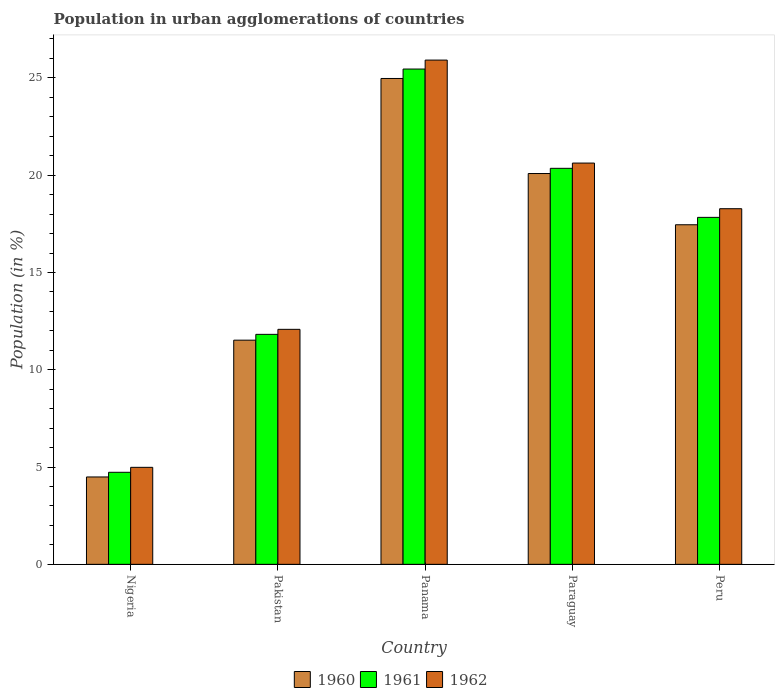How many groups of bars are there?
Offer a terse response. 5. How many bars are there on the 3rd tick from the left?
Your answer should be very brief. 3. What is the label of the 5th group of bars from the left?
Provide a succinct answer. Peru. In how many cases, is the number of bars for a given country not equal to the number of legend labels?
Give a very brief answer. 0. What is the percentage of population in urban agglomerations in 1961 in Peru?
Your response must be concise. 17.83. Across all countries, what is the maximum percentage of population in urban agglomerations in 1960?
Give a very brief answer. 24.97. Across all countries, what is the minimum percentage of population in urban agglomerations in 1962?
Ensure brevity in your answer.  4.99. In which country was the percentage of population in urban agglomerations in 1962 maximum?
Offer a very short reply. Panama. In which country was the percentage of population in urban agglomerations in 1961 minimum?
Ensure brevity in your answer.  Nigeria. What is the total percentage of population in urban agglomerations in 1961 in the graph?
Provide a succinct answer. 80.19. What is the difference between the percentage of population in urban agglomerations in 1960 in Pakistan and that in Peru?
Provide a short and direct response. -5.93. What is the difference between the percentage of population in urban agglomerations in 1960 in Panama and the percentage of population in urban agglomerations in 1962 in Pakistan?
Make the answer very short. 12.89. What is the average percentage of population in urban agglomerations in 1960 per country?
Provide a succinct answer. 15.7. What is the difference between the percentage of population in urban agglomerations of/in 1961 and percentage of population in urban agglomerations of/in 1962 in Nigeria?
Ensure brevity in your answer.  -0.26. What is the ratio of the percentage of population in urban agglomerations in 1960 in Nigeria to that in Paraguay?
Provide a succinct answer. 0.22. Is the percentage of population in urban agglomerations in 1962 in Nigeria less than that in Paraguay?
Your response must be concise. Yes. What is the difference between the highest and the second highest percentage of population in urban agglomerations in 1961?
Provide a succinct answer. 5.1. What is the difference between the highest and the lowest percentage of population in urban agglomerations in 1960?
Give a very brief answer. 20.48. What does the 2nd bar from the left in Peru represents?
Offer a terse response. 1961. How many bars are there?
Your answer should be very brief. 15. What is the difference between two consecutive major ticks on the Y-axis?
Offer a terse response. 5. Does the graph contain grids?
Provide a succinct answer. No. How many legend labels are there?
Give a very brief answer. 3. What is the title of the graph?
Make the answer very short. Population in urban agglomerations of countries. Does "2008" appear as one of the legend labels in the graph?
Your answer should be compact. No. What is the Population (in %) of 1960 in Nigeria?
Make the answer very short. 4.49. What is the Population (in %) of 1961 in Nigeria?
Ensure brevity in your answer.  4.73. What is the Population (in %) of 1962 in Nigeria?
Keep it short and to the point. 4.99. What is the Population (in %) of 1960 in Pakistan?
Make the answer very short. 11.52. What is the Population (in %) in 1961 in Pakistan?
Provide a short and direct response. 11.82. What is the Population (in %) in 1962 in Pakistan?
Give a very brief answer. 12.08. What is the Population (in %) of 1960 in Panama?
Your answer should be very brief. 24.97. What is the Population (in %) in 1961 in Panama?
Ensure brevity in your answer.  25.46. What is the Population (in %) of 1962 in Panama?
Ensure brevity in your answer.  25.92. What is the Population (in %) of 1960 in Paraguay?
Give a very brief answer. 20.08. What is the Population (in %) in 1961 in Paraguay?
Provide a succinct answer. 20.35. What is the Population (in %) of 1962 in Paraguay?
Provide a succinct answer. 20.62. What is the Population (in %) in 1960 in Peru?
Your answer should be very brief. 17.45. What is the Population (in %) in 1961 in Peru?
Make the answer very short. 17.83. What is the Population (in %) of 1962 in Peru?
Provide a succinct answer. 18.28. Across all countries, what is the maximum Population (in %) in 1960?
Your response must be concise. 24.97. Across all countries, what is the maximum Population (in %) in 1961?
Offer a very short reply. 25.46. Across all countries, what is the maximum Population (in %) in 1962?
Your response must be concise. 25.92. Across all countries, what is the minimum Population (in %) of 1960?
Give a very brief answer. 4.49. Across all countries, what is the minimum Population (in %) of 1961?
Your answer should be compact. 4.73. Across all countries, what is the minimum Population (in %) in 1962?
Provide a short and direct response. 4.99. What is the total Population (in %) in 1960 in the graph?
Your response must be concise. 78.52. What is the total Population (in %) of 1961 in the graph?
Provide a succinct answer. 80.19. What is the total Population (in %) of 1962 in the graph?
Give a very brief answer. 81.88. What is the difference between the Population (in %) in 1960 in Nigeria and that in Pakistan?
Your response must be concise. -7.03. What is the difference between the Population (in %) of 1961 in Nigeria and that in Pakistan?
Your response must be concise. -7.09. What is the difference between the Population (in %) in 1962 in Nigeria and that in Pakistan?
Offer a terse response. -7.09. What is the difference between the Population (in %) of 1960 in Nigeria and that in Panama?
Provide a short and direct response. -20.48. What is the difference between the Population (in %) in 1961 in Nigeria and that in Panama?
Ensure brevity in your answer.  -20.72. What is the difference between the Population (in %) in 1962 in Nigeria and that in Panama?
Make the answer very short. -20.93. What is the difference between the Population (in %) in 1960 in Nigeria and that in Paraguay?
Keep it short and to the point. -15.59. What is the difference between the Population (in %) of 1961 in Nigeria and that in Paraguay?
Keep it short and to the point. -15.62. What is the difference between the Population (in %) of 1962 in Nigeria and that in Paraguay?
Provide a succinct answer. -15.64. What is the difference between the Population (in %) in 1960 in Nigeria and that in Peru?
Give a very brief answer. -12.96. What is the difference between the Population (in %) in 1961 in Nigeria and that in Peru?
Your answer should be compact. -13.1. What is the difference between the Population (in %) of 1962 in Nigeria and that in Peru?
Your answer should be very brief. -13.29. What is the difference between the Population (in %) of 1960 in Pakistan and that in Panama?
Keep it short and to the point. -13.45. What is the difference between the Population (in %) of 1961 in Pakistan and that in Panama?
Your response must be concise. -13.64. What is the difference between the Population (in %) in 1962 in Pakistan and that in Panama?
Offer a very short reply. -13.84. What is the difference between the Population (in %) in 1960 in Pakistan and that in Paraguay?
Your answer should be very brief. -8.56. What is the difference between the Population (in %) of 1961 in Pakistan and that in Paraguay?
Your answer should be compact. -8.53. What is the difference between the Population (in %) of 1962 in Pakistan and that in Paraguay?
Offer a terse response. -8.55. What is the difference between the Population (in %) of 1960 in Pakistan and that in Peru?
Offer a very short reply. -5.93. What is the difference between the Population (in %) of 1961 in Pakistan and that in Peru?
Offer a very short reply. -6.01. What is the difference between the Population (in %) of 1962 in Pakistan and that in Peru?
Your answer should be compact. -6.2. What is the difference between the Population (in %) in 1960 in Panama and that in Paraguay?
Ensure brevity in your answer.  4.89. What is the difference between the Population (in %) in 1961 in Panama and that in Paraguay?
Offer a very short reply. 5.1. What is the difference between the Population (in %) of 1962 in Panama and that in Paraguay?
Your response must be concise. 5.29. What is the difference between the Population (in %) of 1960 in Panama and that in Peru?
Offer a terse response. 7.52. What is the difference between the Population (in %) of 1961 in Panama and that in Peru?
Make the answer very short. 7.62. What is the difference between the Population (in %) of 1962 in Panama and that in Peru?
Provide a short and direct response. 7.64. What is the difference between the Population (in %) of 1960 in Paraguay and that in Peru?
Give a very brief answer. 2.63. What is the difference between the Population (in %) of 1961 in Paraguay and that in Peru?
Your answer should be compact. 2.52. What is the difference between the Population (in %) in 1962 in Paraguay and that in Peru?
Provide a short and direct response. 2.35. What is the difference between the Population (in %) of 1960 in Nigeria and the Population (in %) of 1961 in Pakistan?
Make the answer very short. -7.33. What is the difference between the Population (in %) of 1960 in Nigeria and the Population (in %) of 1962 in Pakistan?
Keep it short and to the point. -7.59. What is the difference between the Population (in %) of 1961 in Nigeria and the Population (in %) of 1962 in Pakistan?
Provide a succinct answer. -7.35. What is the difference between the Population (in %) in 1960 in Nigeria and the Population (in %) in 1961 in Panama?
Your answer should be very brief. -20.96. What is the difference between the Population (in %) of 1960 in Nigeria and the Population (in %) of 1962 in Panama?
Keep it short and to the point. -21.42. What is the difference between the Population (in %) in 1961 in Nigeria and the Population (in %) in 1962 in Panama?
Provide a succinct answer. -21.18. What is the difference between the Population (in %) of 1960 in Nigeria and the Population (in %) of 1961 in Paraguay?
Your answer should be very brief. -15.86. What is the difference between the Population (in %) of 1960 in Nigeria and the Population (in %) of 1962 in Paraguay?
Offer a terse response. -16.13. What is the difference between the Population (in %) of 1961 in Nigeria and the Population (in %) of 1962 in Paraguay?
Make the answer very short. -15.89. What is the difference between the Population (in %) in 1960 in Nigeria and the Population (in %) in 1961 in Peru?
Offer a terse response. -13.34. What is the difference between the Population (in %) in 1960 in Nigeria and the Population (in %) in 1962 in Peru?
Keep it short and to the point. -13.79. What is the difference between the Population (in %) of 1961 in Nigeria and the Population (in %) of 1962 in Peru?
Ensure brevity in your answer.  -13.55. What is the difference between the Population (in %) of 1960 in Pakistan and the Population (in %) of 1961 in Panama?
Offer a terse response. -13.93. What is the difference between the Population (in %) of 1960 in Pakistan and the Population (in %) of 1962 in Panama?
Your answer should be very brief. -14.39. What is the difference between the Population (in %) in 1961 in Pakistan and the Population (in %) in 1962 in Panama?
Your response must be concise. -14.1. What is the difference between the Population (in %) of 1960 in Pakistan and the Population (in %) of 1961 in Paraguay?
Provide a short and direct response. -8.83. What is the difference between the Population (in %) of 1960 in Pakistan and the Population (in %) of 1962 in Paraguay?
Make the answer very short. -9.1. What is the difference between the Population (in %) of 1961 in Pakistan and the Population (in %) of 1962 in Paraguay?
Provide a short and direct response. -8.8. What is the difference between the Population (in %) of 1960 in Pakistan and the Population (in %) of 1961 in Peru?
Your answer should be compact. -6.31. What is the difference between the Population (in %) in 1960 in Pakistan and the Population (in %) in 1962 in Peru?
Provide a succinct answer. -6.76. What is the difference between the Population (in %) of 1961 in Pakistan and the Population (in %) of 1962 in Peru?
Offer a terse response. -6.46. What is the difference between the Population (in %) of 1960 in Panama and the Population (in %) of 1961 in Paraguay?
Make the answer very short. 4.62. What is the difference between the Population (in %) in 1960 in Panama and the Population (in %) in 1962 in Paraguay?
Your response must be concise. 4.35. What is the difference between the Population (in %) of 1961 in Panama and the Population (in %) of 1962 in Paraguay?
Your answer should be very brief. 4.83. What is the difference between the Population (in %) of 1960 in Panama and the Population (in %) of 1961 in Peru?
Ensure brevity in your answer.  7.14. What is the difference between the Population (in %) in 1960 in Panama and the Population (in %) in 1962 in Peru?
Give a very brief answer. 6.69. What is the difference between the Population (in %) in 1961 in Panama and the Population (in %) in 1962 in Peru?
Keep it short and to the point. 7.18. What is the difference between the Population (in %) in 1960 in Paraguay and the Population (in %) in 1961 in Peru?
Ensure brevity in your answer.  2.25. What is the difference between the Population (in %) of 1960 in Paraguay and the Population (in %) of 1962 in Peru?
Your response must be concise. 1.81. What is the difference between the Population (in %) of 1961 in Paraguay and the Population (in %) of 1962 in Peru?
Keep it short and to the point. 2.08. What is the average Population (in %) in 1960 per country?
Your answer should be very brief. 15.7. What is the average Population (in %) of 1961 per country?
Provide a succinct answer. 16.04. What is the average Population (in %) in 1962 per country?
Ensure brevity in your answer.  16.38. What is the difference between the Population (in %) of 1960 and Population (in %) of 1961 in Nigeria?
Your answer should be compact. -0.24. What is the difference between the Population (in %) in 1960 and Population (in %) in 1962 in Nigeria?
Provide a short and direct response. -0.49. What is the difference between the Population (in %) in 1961 and Population (in %) in 1962 in Nigeria?
Keep it short and to the point. -0.26. What is the difference between the Population (in %) in 1960 and Population (in %) in 1961 in Pakistan?
Ensure brevity in your answer.  -0.3. What is the difference between the Population (in %) in 1960 and Population (in %) in 1962 in Pakistan?
Provide a succinct answer. -0.56. What is the difference between the Population (in %) of 1961 and Population (in %) of 1962 in Pakistan?
Ensure brevity in your answer.  -0.26. What is the difference between the Population (in %) in 1960 and Population (in %) in 1961 in Panama?
Keep it short and to the point. -0.48. What is the difference between the Population (in %) in 1960 and Population (in %) in 1962 in Panama?
Your answer should be compact. -0.94. What is the difference between the Population (in %) of 1961 and Population (in %) of 1962 in Panama?
Give a very brief answer. -0.46. What is the difference between the Population (in %) in 1960 and Population (in %) in 1961 in Paraguay?
Give a very brief answer. -0.27. What is the difference between the Population (in %) of 1960 and Population (in %) of 1962 in Paraguay?
Give a very brief answer. -0.54. What is the difference between the Population (in %) of 1961 and Population (in %) of 1962 in Paraguay?
Keep it short and to the point. -0.27. What is the difference between the Population (in %) of 1960 and Population (in %) of 1961 in Peru?
Ensure brevity in your answer.  -0.38. What is the difference between the Population (in %) in 1960 and Population (in %) in 1962 in Peru?
Give a very brief answer. -0.82. What is the difference between the Population (in %) of 1961 and Population (in %) of 1962 in Peru?
Offer a terse response. -0.44. What is the ratio of the Population (in %) of 1960 in Nigeria to that in Pakistan?
Ensure brevity in your answer.  0.39. What is the ratio of the Population (in %) of 1961 in Nigeria to that in Pakistan?
Ensure brevity in your answer.  0.4. What is the ratio of the Population (in %) of 1962 in Nigeria to that in Pakistan?
Provide a short and direct response. 0.41. What is the ratio of the Population (in %) in 1960 in Nigeria to that in Panama?
Give a very brief answer. 0.18. What is the ratio of the Population (in %) in 1961 in Nigeria to that in Panama?
Offer a very short reply. 0.19. What is the ratio of the Population (in %) in 1962 in Nigeria to that in Panama?
Your answer should be compact. 0.19. What is the ratio of the Population (in %) in 1960 in Nigeria to that in Paraguay?
Provide a succinct answer. 0.22. What is the ratio of the Population (in %) in 1961 in Nigeria to that in Paraguay?
Offer a terse response. 0.23. What is the ratio of the Population (in %) of 1962 in Nigeria to that in Paraguay?
Your answer should be very brief. 0.24. What is the ratio of the Population (in %) of 1960 in Nigeria to that in Peru?
Your answer should be compact. 0.26. What is the ratio of the Population (in %) of 1961 in Nigeria to that in Peru?
Your response must be concise. 0.27. What is the ratio of the Population (in %) in 1962 in Nigeria to that in Peru?
Keep it short and to the point. 0.27. What is the ratio of the Population (in %) in 1960 in Pakistan to that in Panama?
Keep it short and to the point. 0.46. What is the ratio of the Population (in %) in 1961 in Pakistan to that in Panama?
Your answer should be very brief. 0.46. What is the ratio of the Population (in %) of 1962 in Pakistan to that in Panama?
Offer a terse response. 0.47. What is the ratio of the Population (in %) in 1960 in Pakistan to that in Paraguay?
Your response must be concise. 0.57. What is the ratio of the Population (in %) of 1961 in Pakistan to that in Paraguay?
Your answer should be very brief. 0.58. What is the ratio of the Population (in %) in 1962 in Pakistan to that in Paraguay?
Ensure brevity in your answer.  0.59. What is the ratio of the Population (in %) in 1960 in Pakistan to that in Peru?
Keep it short and to the point. 0.66. What is the ratio of the Population (in %) of 1961 in Pakistan to that in Peru?
Provide a succinct answer. 0.66. What is the ratio of the Population (in %) in 1962 in Pakistan to that in Peru?
Give a very brief answer. 0.66. What is the ratio of the Population (in %) of 1960 in Panama to that in Paraguay?
Give a very brief answer. 1.24. What is the ratio of the Population (in %) in 1961 in Panama to that in Paraguay?
Ensure brevity in your answer.  1.25. What is the ratio of the Population (in %) in 1962 in Panama to that in Paraguay?
Your response must be concise. 1.26. What is the ratio of the Population (in %) in 1960 in Panama to that in Peru?
Make the answer very short. 1.43. What is the ratio of the Population (in %) of 1961 in Panama to that in Peru?
Your answer should be compact. 1.43. What is the ratio of the Population (in %) in 1962 in Panama to that in Peru?
Offer a very short reply. 1.42. What is the ratio of the Population (in %) of 1960 in Paraguay to that in Peru?
Your response must be concise. 1.15. What is the ratio of the Population (in %) of 1961 in Paraguay to that in Peru?
Your answer should be very brief. 1.14. What is the ratio of the Population (in %) of 1962 in Paraguay to that in Peru?
Give a very brief answer. 1.13. What is the difference between the highest and the second highest Population (in %) of 1960?
Offer a very short reply. 4.89. What is the difference between the highest and the second highest Population (in %) in 1961?
Your response must be concise. 5.1. What is the difference between the highest and the second highest Population (in %) of 1962?
Your answer should be very brief. 5.29. What is the difference between the highest and the lowest Population (in %) of 1960?
Provide a succinct answer. 20.48. What is the difference between the highest and the lowest Population (in %) in 1961?
Keep it short and to the point. 20.72. What is the difference between the highest and the lowest Population (in %) in 1962?
Offer a terse response. 20.93. 